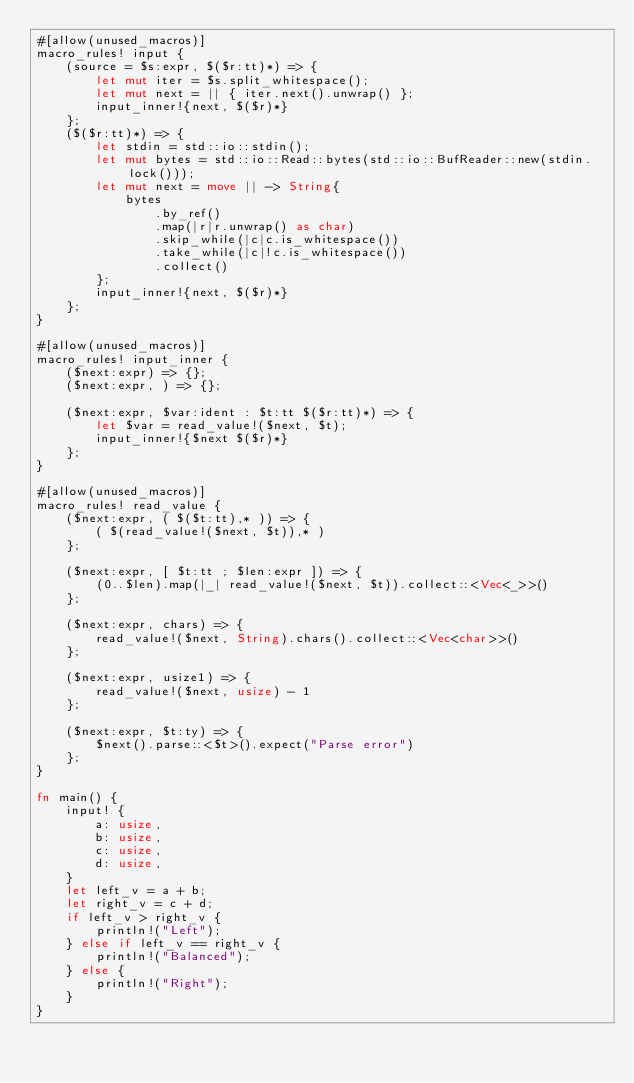Convert code to text. <code><loc_0><loc_0><loc_500><loc_500><_Rust_>#[allow(unused_macros)]
macro_rules! input {
    (source = $s:expr, $($r:tt)*) => {
        let mut iter = $s.split_whitespace();
        let mut next = || { iter.next().unwrap() };
        input_inner!{next, $($r)*}
    };
    ($($r:tt)*) => {
        let stdin = std::io::stdin();
        let mut bytes = std::io::Read::bytes(std::io::BufReader::new(stdin.lock()));
        let mut next = move || -> String{
            bytes
                .by_ref()
                .map(|r|r.unwrap() as char)
                .skip_while(|c|c.is_whitespace())
                .take_while(|c|!c.is_whitespace())
                .collect()
        };
        input_inner!{next, $($r)*}
    };
}

#[allow(unused_macros)]
macro_rules! input_inner {
    ($next:expr) => {};
    ($next:expr, ) => {};

    ($next:expr, $var:ident : $t:tt $($r:tt)*) => {
        let $var = read_value!($next, $t);
        input_inner!{$next $($r)*}
    };
}

#[allow(unused_macros)]
macro_rules! read_value {
    ($next:expr, ( $($t:tt),* )) => {
        ( $(read_value!($next, $t)),* )
    };

    ($next:expr, [ $t:tt ; $len:expr ]) => {
        (0..$len).map(|_| read_value!($next, $t)).collect::<Vec<_>>()
    };

    ($next:expr, chars) => {
        read_value!($next, String).chars().collect::<Vec<char>>()
    };

    ($next:expr, usize1) => {
        read_value!($next, usize) - 1
    };

    ($next:expr, $t:ty) => {
        $next().parse::<$t>().expect("Parse error")
    };
}

fn main() {
    input! {
        a: usize,
        b: usize,
        c: usize,
        d: usize,
    }
    let left_v = a + b;
    let right_v = c + d;
    if left_v > right_v {
        println!("Left");
    } else if left_v == right_v {
        println!("Balanced");
    } else {
        println!("Right");
    }
}</code> 